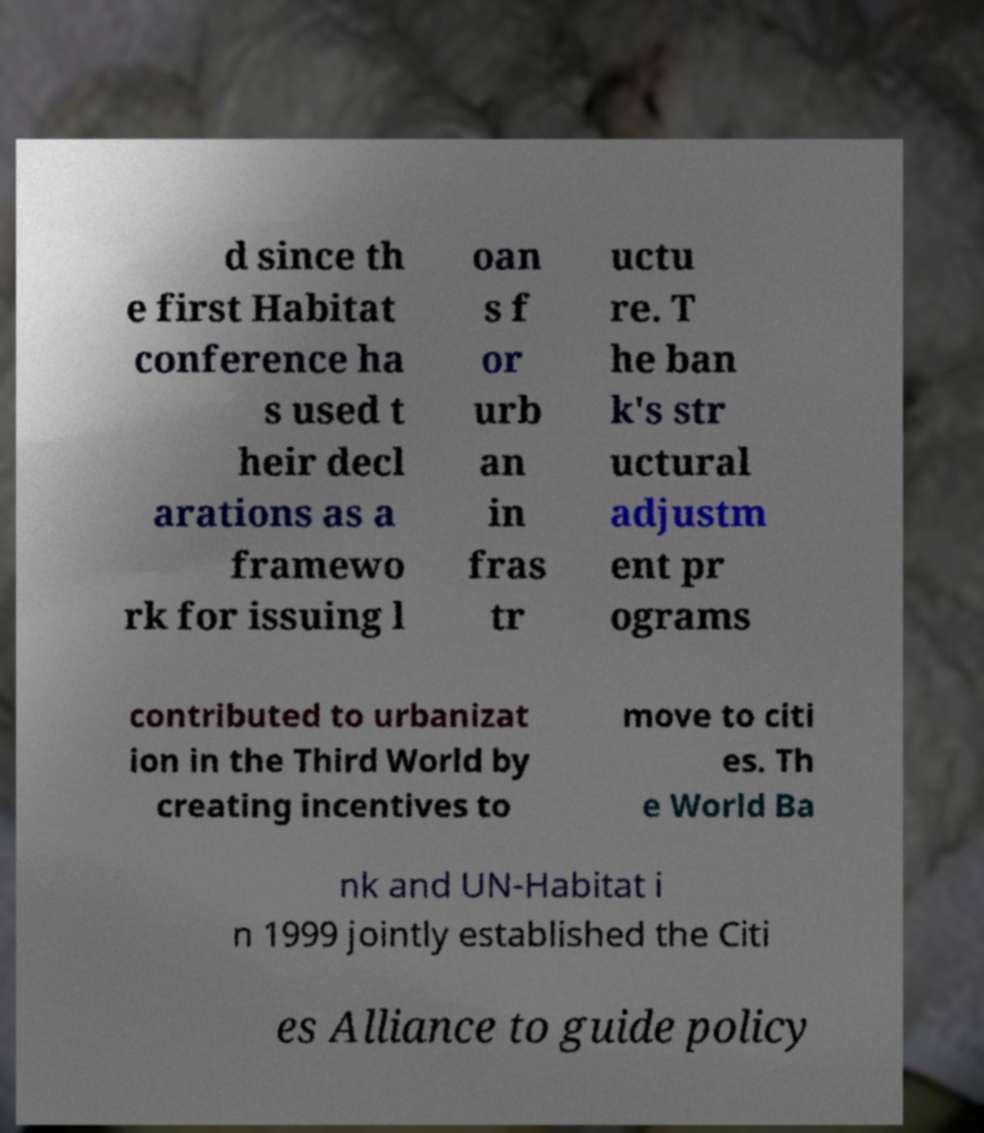Please read and relay the text visible in this image. What does it say? d since th e first Habitat conference ha s used t heir decl arations as a framewo rk for issuing l oan s f or urb an in fras tr uctu re. T he ban k's str uctural adjustm ent pr ograms contributed to urbanizat ion in the Third World by creating incentives to move to citi es. Th e World Ba nk and UN-Habitat i n 1999 jointly established the Citi es Alliance to guide policy 